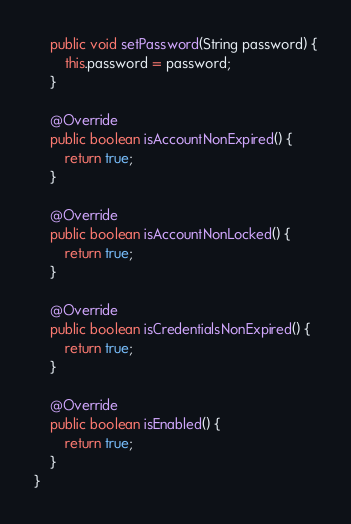Convert code to text. <code><loc_0><loc_0><loc_500><loc_500><_Java_>
	public void setPassword(String password) {
		this.password = password;
	}

	@Override
	public boolean isAccountNonExpired() {
		return true;
	}

	@Override
	public boolean isAccountNonLocked() {
		return true;
	}

	@Override
	public boolean isCredentialsNonExpired() {
		return true;
	}

	@Override
	public boolean isEnabled() {
		return true;
	}
}
</code> 